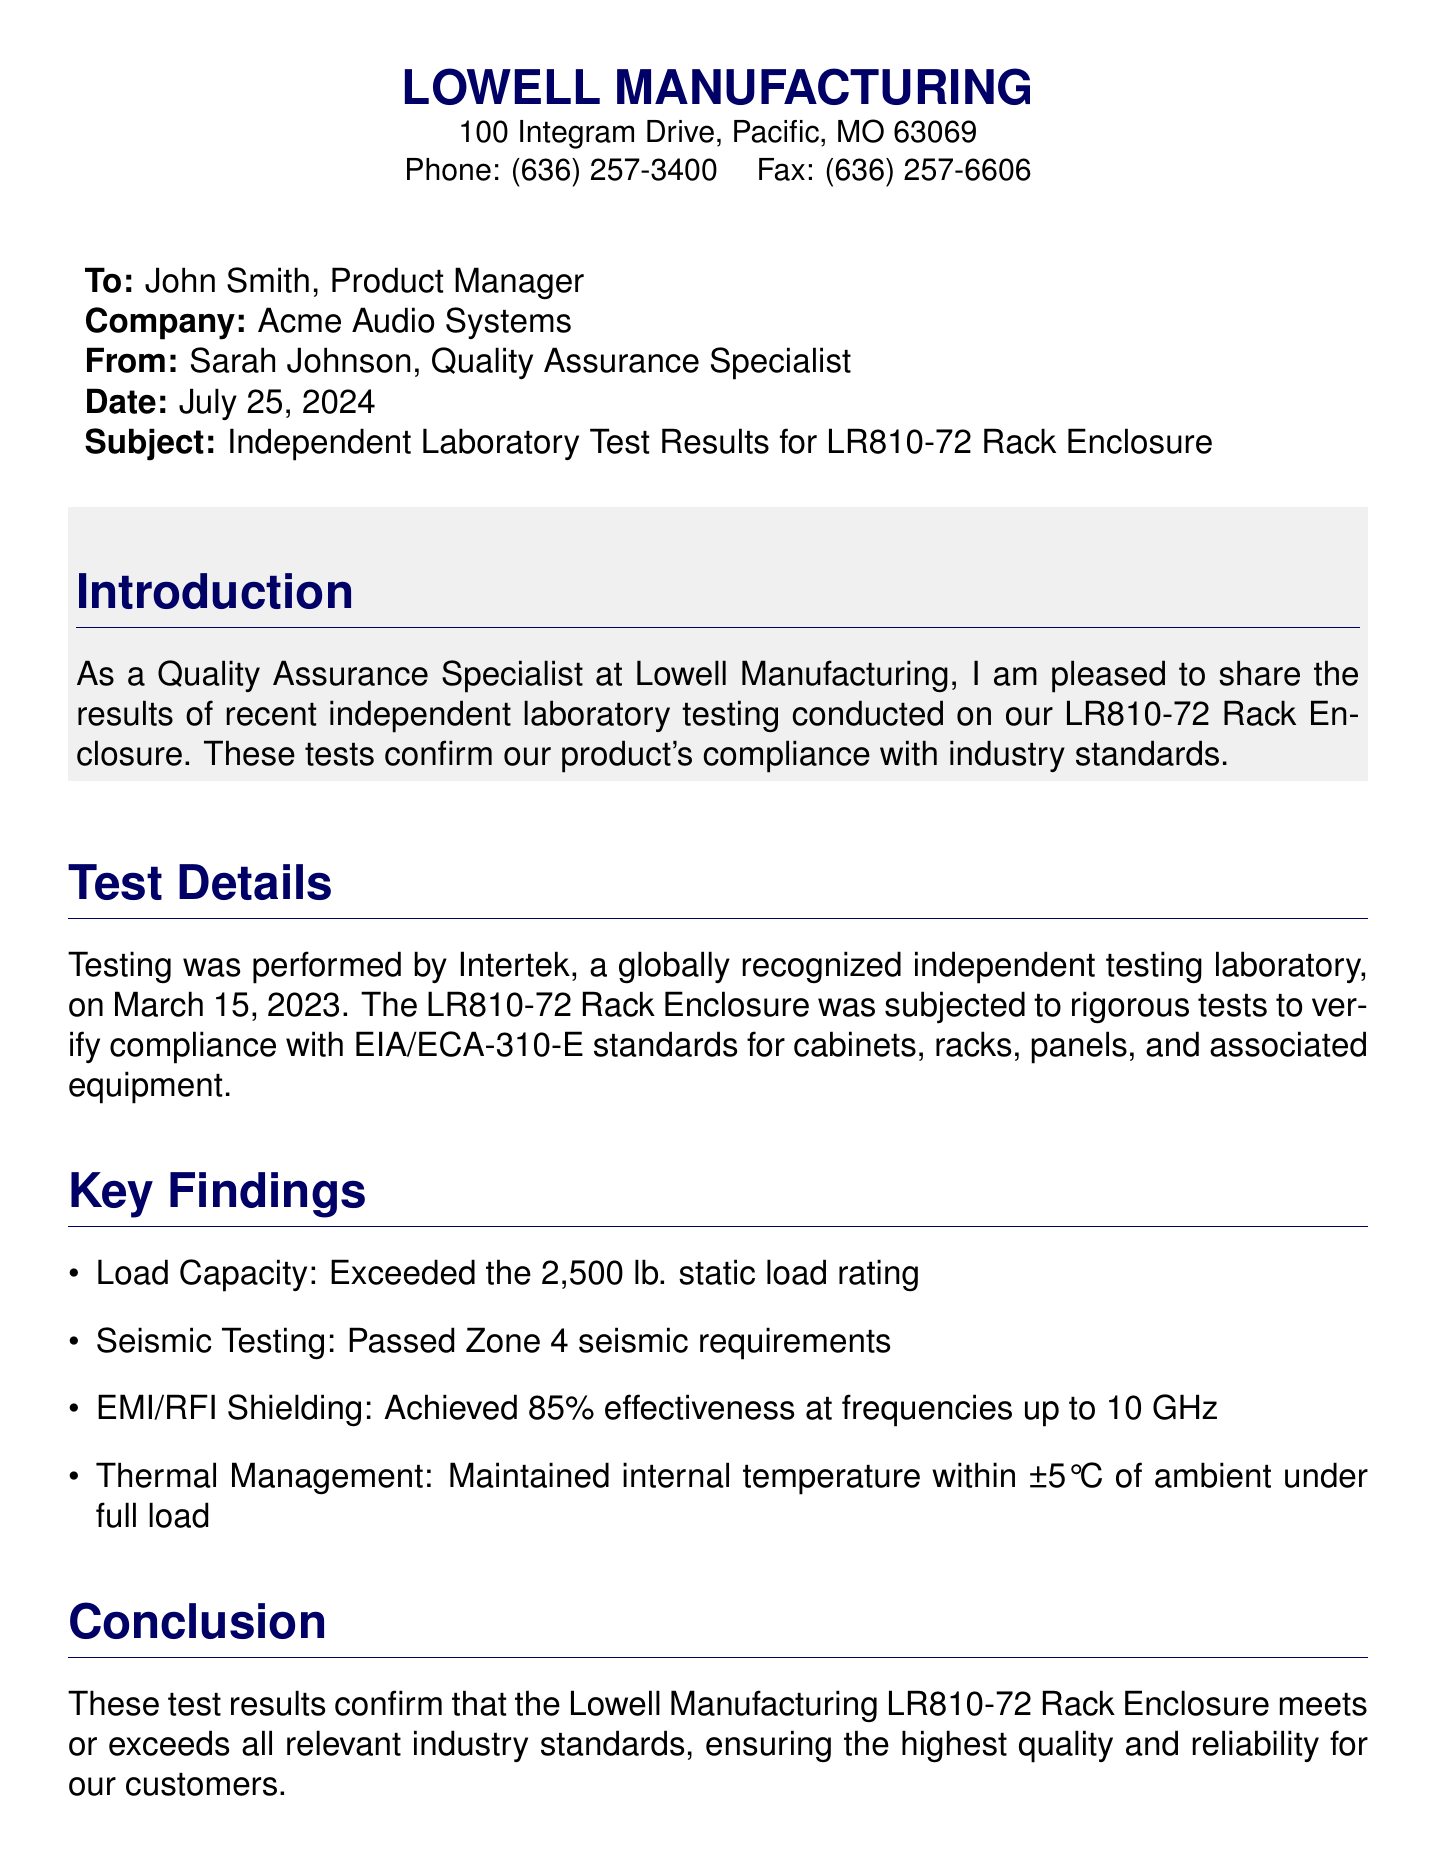What is the date of the test? The date of the test is specifically mentioned in the document as March 15, 2023.
Answer: March 15, 2023 Who conducted the testing? The testing was performed by a recognized independent laboratory, which is identified as Intertek in the document.
Answer: Intertek What product is being tested? The document specifies the product being tested is the LR810-72 Rack Enclosure.
Answer: LR810-72 Rack Enclosure What is the load capacity of the product? The document states that the load capacity exceeded the rating specified, which is 2,500 lb.
Answer: 2,500 lb What is the effectiveness of EMI/RFI shielding at high frequencies? The effectiveness of EMI/RFI shielding is noted to be 85% at frequencies up to 10 GHz.
Answer: 85% What are the seismic testing requirements passed by the product? The seismic testing requirements that the LR810-72 Rack Enclosure passed are credited to Zone 4 standards.
Answer: Zone 4 What company is the fax addressed to? The fax is addressed to John Smith, who is the Product Manager at Acme Audio Systems.
Answer: Acme Audio Systems What is the title of the sender? The sender's title is mentioned as Quality Assurance Specialist in the document.
Answer: Quality Assurance Specialist 